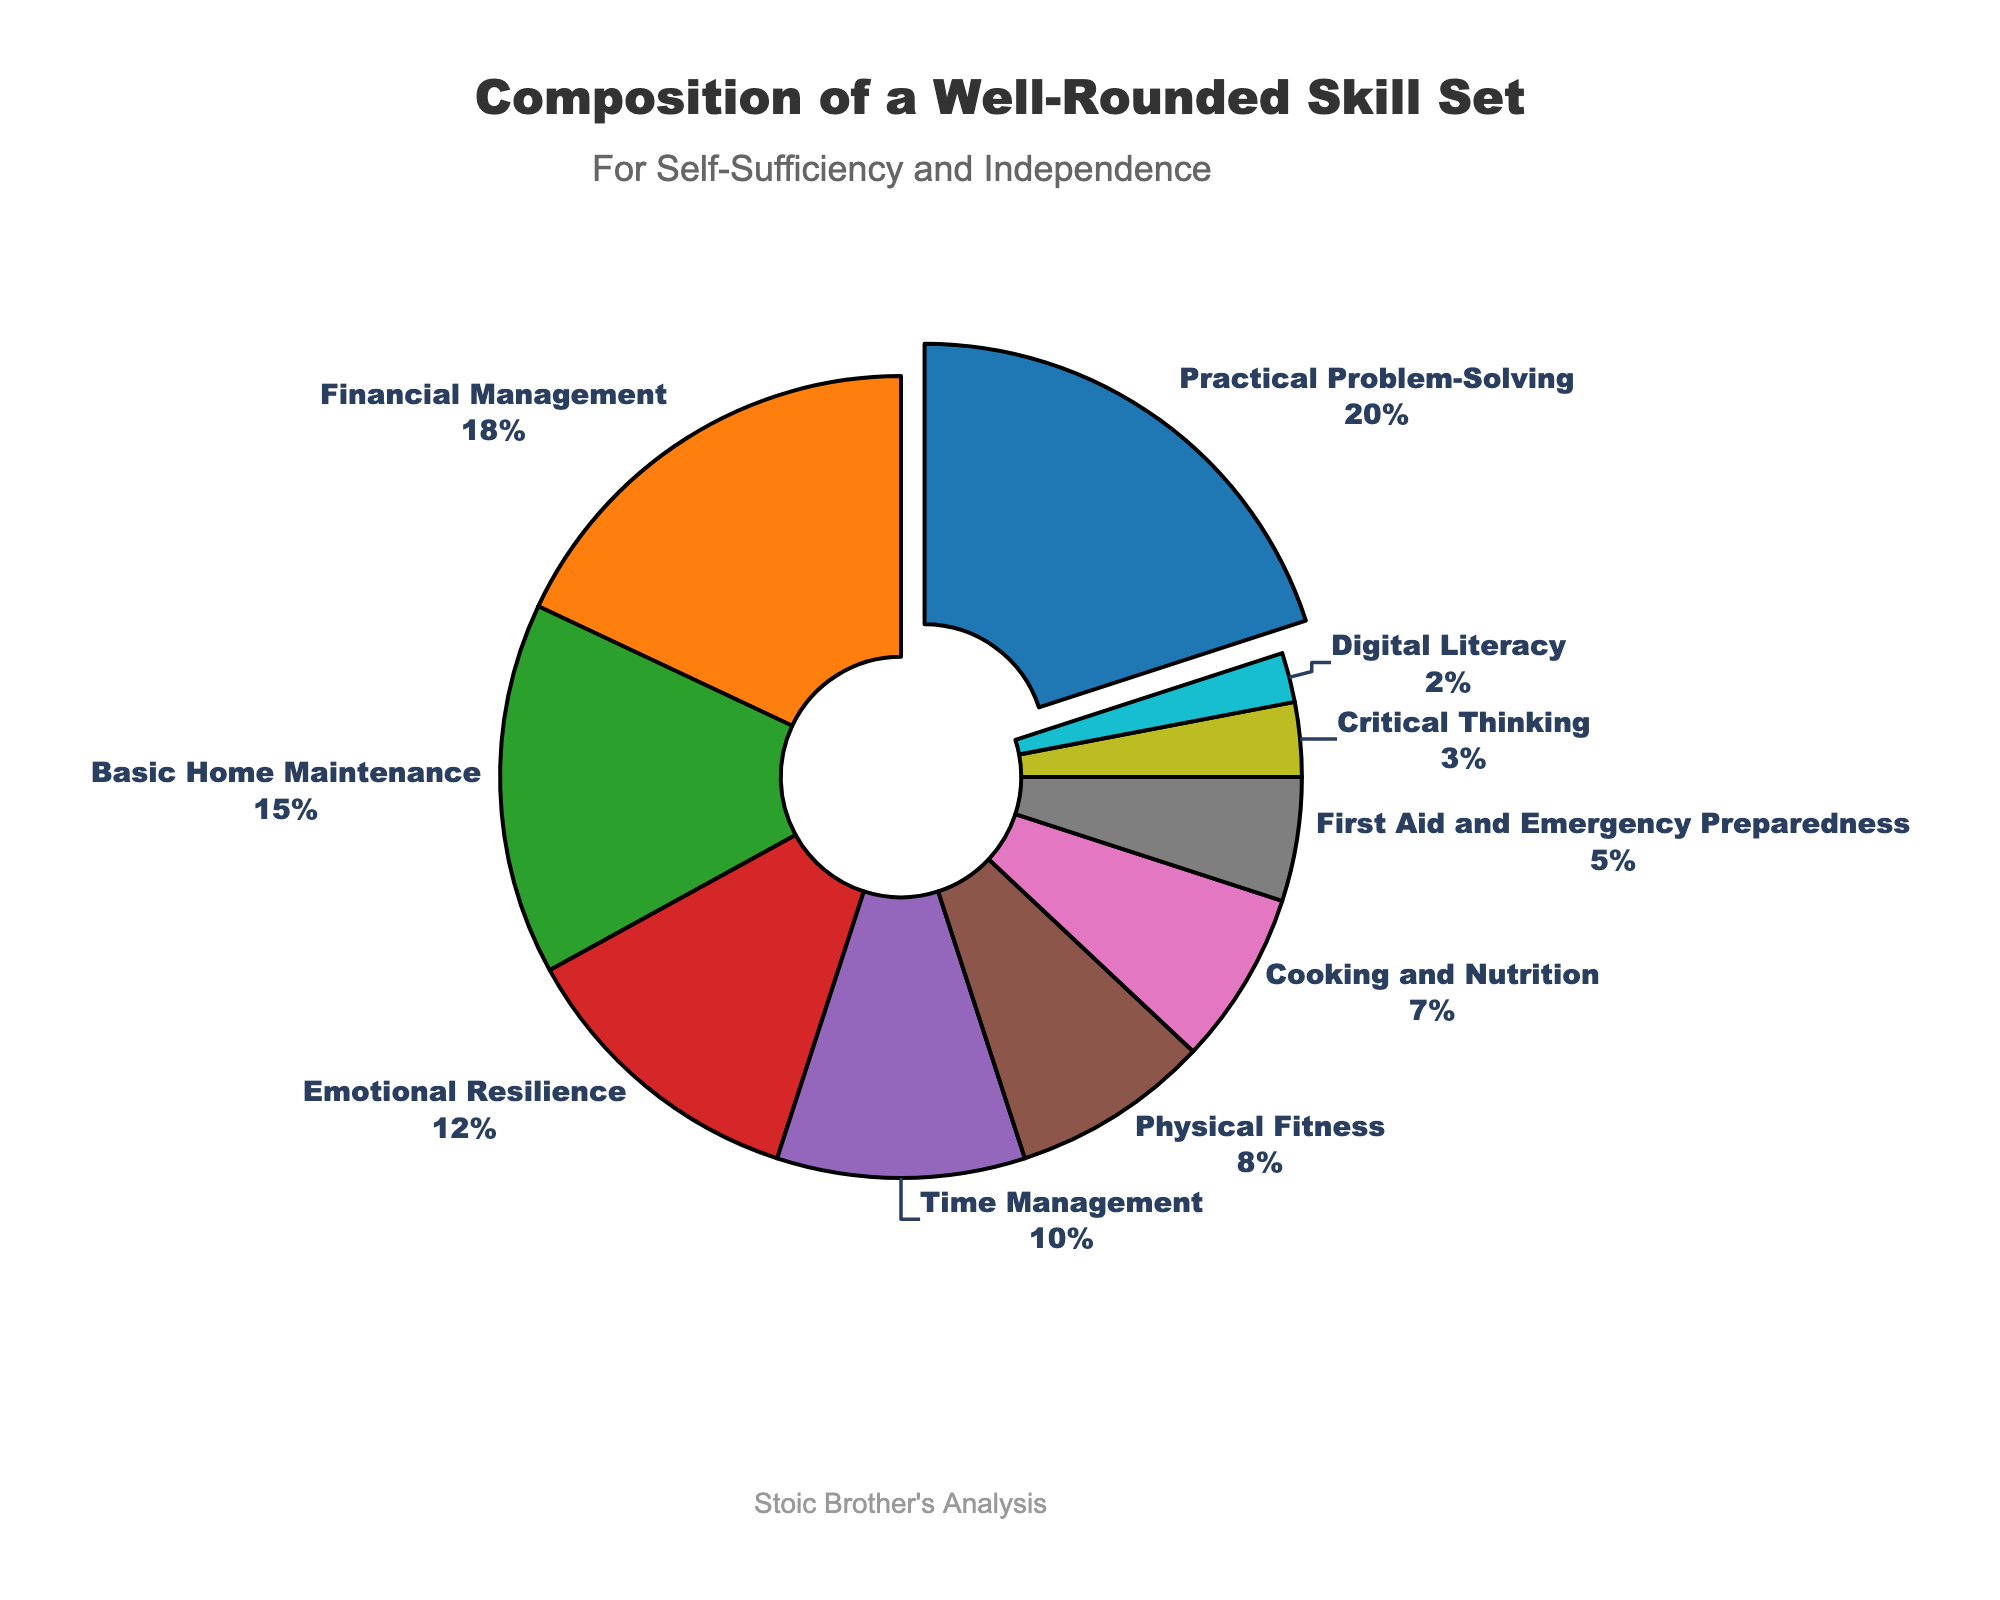What skill has the highest percentage in the pie chart? The skill with the highest percentage occupies the largest segment of the pie chart. Upon inspecting the chart, "Practical Problem-Solving" has the largest segment.
Answer: Practical Problem-Solving Which two skills together make up the largest combined percentage? To find the two skills with the largest combined percentage, we identify the two largest segments in the pie chart, which are "Practical Problem-Solving" and "Financial Management." Adding their percentages, 20% + 18% = 38%.
Answer: Practical Problem-Solving and Financial Management What is the total percentage of all the skills related to physical well-being? Skills related to physical well-being from the data are "Physical Fitness" and partially "First Aid and Emergency Preparedness." Their percentages are 8% and 5% respectively. Adding them gives 8% + 5% = 13%.
Answer: 13% How does the percentage of Financial Management compare to Basic Home Maintenance? By comparing the segments, "Financial Management" has a percentage of 18%, while "Basic Home Maintenance" has 15%. Thus, Financial Management is higher than Basic Home Maintenance by 3%.
Answer: Financial Management is 3% higher Which skill has the smallest percentage, and what is it? The smallest segment of the pie chart corresponds to the skill "Digital Literacy" with a percentage of 2%.
Answer: Digital Literacy with 2% What is the difference between the percentages of Emotional Resilience and Critical Thinking? To find the difference, subtract the smaller segment percentage from the larger one: Emotional Resilience (12%) - Critical Thinking (3%) = 9%.
Answer: 9% How many skills have a percentage greater than or equal to 10%? We identify all segments with percentages 10% or higher: Practical Problem-Solving (20%), Financial Management (18%), Basic Home Maintenance (15%), and Emotional Resilience (12%), Time Management (10%). Thus, 5 skills meet this criterion.
Answer: 5 What total percentage do the three smallest skills contribute to the composition? Identifying the three smallest segments, we have "Digital Literacy" (2%), "Critical Thinking" (3%), and "First Aid and Emergency Preparedness" (5%). Adding their percentages gives 2% + 3% + 5% = 10%.
Answer: 10% What fraction of the pie chart is composed of Cooking and Nutrition and Digital Literacy combined? Adding the percentages of "Cooking and Nutrition" (7%) and "Digital Literacy" (2%) gives 7% + 2% = 9%.
Answer: 9% 